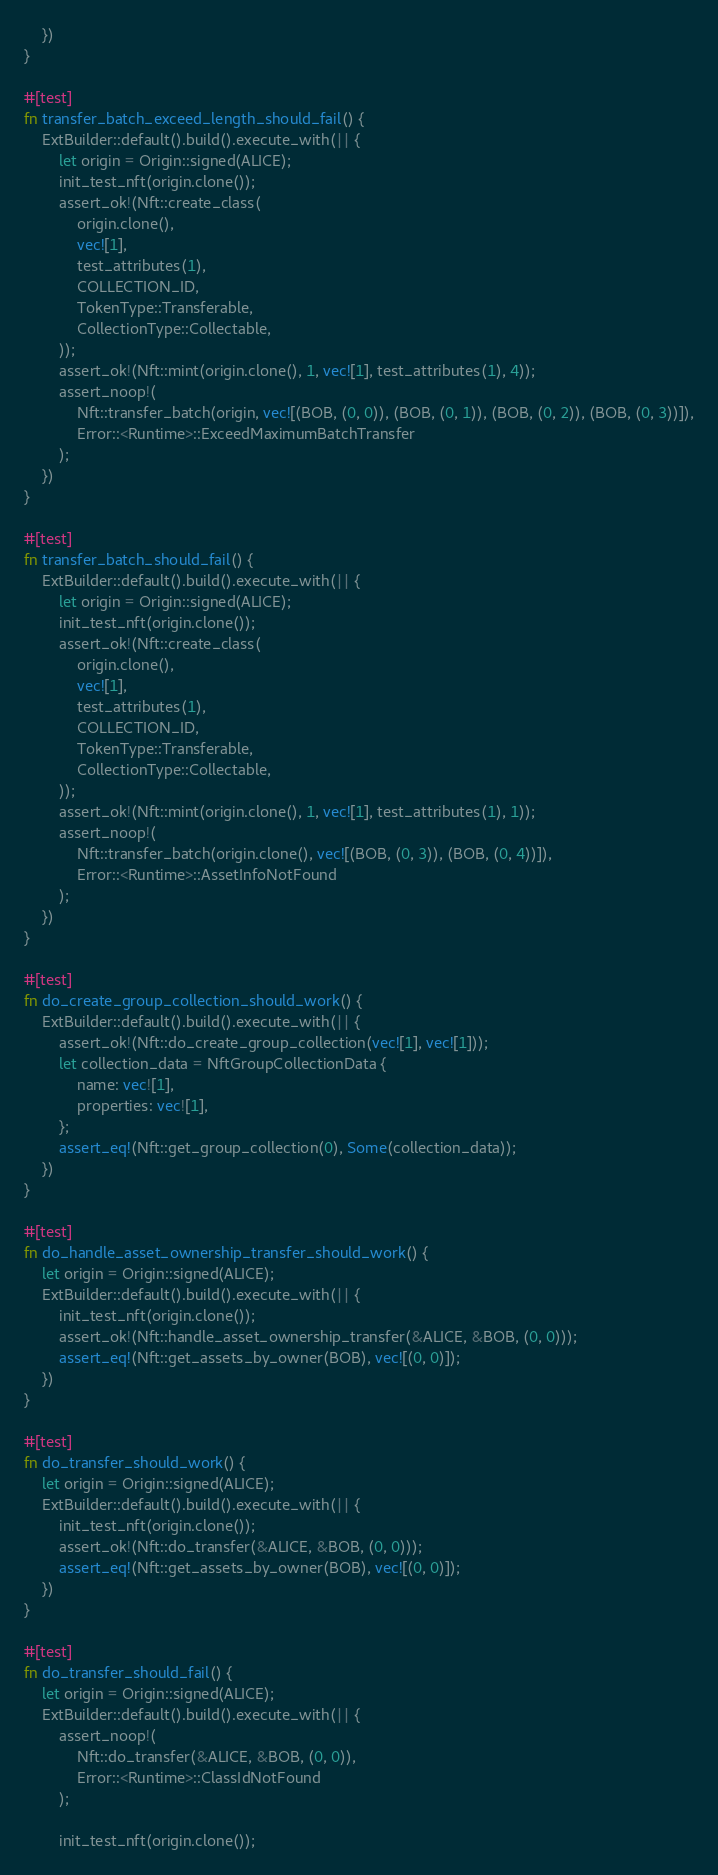Convert code to text. <code><loc_0><loc_0><loc_500><loc_500><_Rust_>	})
}

#[test]
fn transfer_batch_exceed_length_should_fail() {
	ExtBuilder::default().build().execute_with(|| {
		let origin = Origin::signed(ALICE);
		init_test_nft(origin.clone());
		assert_ok!(Nft::create_class(
			origin.clone(),
			vec![1],
			test_attributes(1),
			COLLECTION_ID,
			TokenType::Transferable,
			CollectionType::Collectable,
		));
		assert_ok!(Nft::mint(origin.clone(), 1, vec![1], test_attributes(1), 4));
		assert_noop!(
			Nft::transfer_batch(origin, vec![(BOB, (0, 0)), (BOB, (0, 1)), (BOB, (0, 2)), (BOB, (0, 3))]),
			Error::<Runtime>::ExceedMaximumBatchTransfer
		);
	})
}

#[test]
fn transfer_batch_should_fail() {
	ExtBuilder::default().build().execute_with(|| {
		let origin = Origin::signed(ALICE);
		init_test_nft(origin.clone());
		assert_ok!(Nft::create_class(
			origin.clone(),
			vec![1],
			test_attributes(1),
			COLLECTION_ID,
			TokenType::Transferable,
			CollectionType::Collectable,
		));
		assert_ok!(Nft::mint(origin.clone(), 1, vec![1], test_attributes(1), 1));
		assert_noop!(
			Nft::transfer_batch(origin.clone(), vec![(BOB, (0, 3)), (BOB, (0, 4))]),
			Error::<Runtime>::AssetInfoNotFound
		);
	})
}

#[test]
fn do_create_group_collection_should_work() {
	ExtBuilder::default().build().execute_with(|| {
		assert_ok!(Nft::do_create_group_collection(vec![1], vec![1]));
		let collection_data = NftGroupCollectionData {
			name: vec![1],
			properties: vec![1],
		};
		assert_eq!(Nft::get_group_collection(0), Some(collection_data));
	})
}

#[test]
fn do_handle_asset_ownership_transfer_should_work() {
	let origin = Origin::signed(ALICE);
	ExtBuilder::default().build().execute_with(|| {
		init_test_nft(origin.clone());
		assert_ok!(Nft::handle_asset_ownership_transfer(&ALICE, &BOB, (0, 0)));
		assert_eq!(Nft::get_assets_by_owner(BOB), vec![(0, 0)]);
	})
}

#[test]
fn do_transfer_should_work() {
	let origin = Origin::signed(ALICE);
	ExtBuilder::default().build().execute_with(|| {
		init_test_nft(origin.clone());
		assert_ok!(Nft::do_transfer(&ALICE, &BOB, (0, 0)));
		assert_eq!(Nft::get_assets_by_owner(BOB), vec![(0, 0)]);
	})
}

#[test]
fn do_transfer_should_fail() {
	let origin = Origin::signed(ALICE);
	ExtBuilder::default().build().execute_with(|| {
		assert_noop!(
			Nft::do_transfer(&ALICE, &BOB, (0, 0)),
			Error::<Runtime>::ClassIdNotFound
		);

		init_test_nft(origin.clone());
</code> 